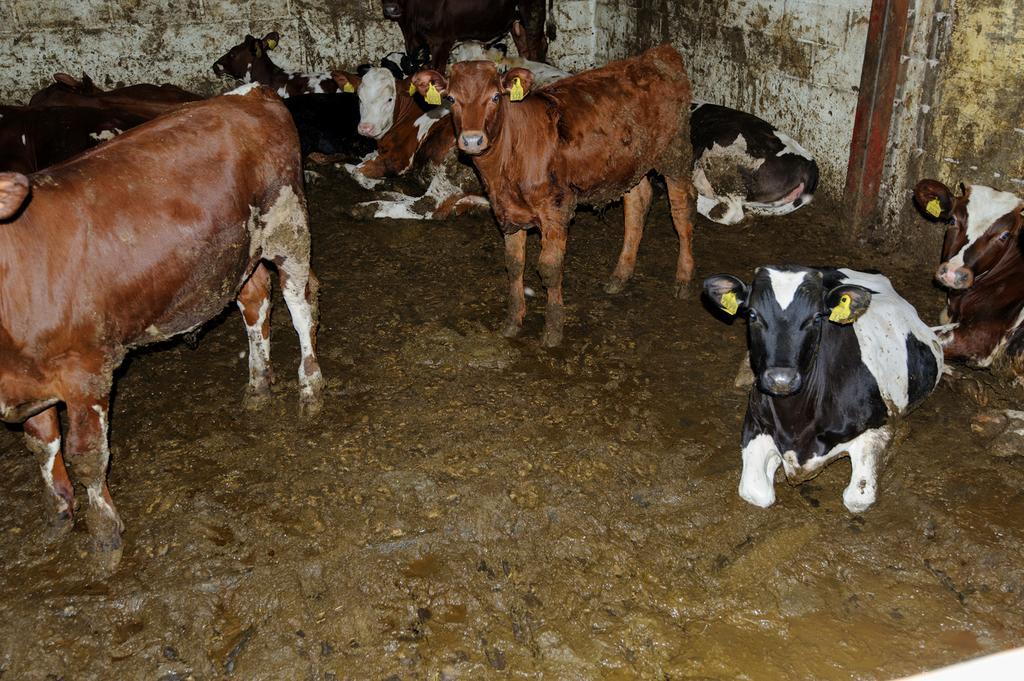In one or two sentences, can you explain what this image depicts? In this picture we can see there are a group of cows sitting and two cows are standing. Behind the cows there is a wall. 